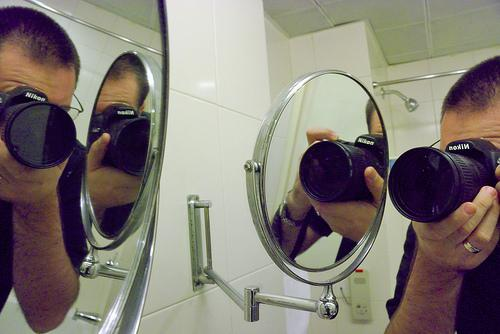Question: what is the man doing?
Choices:
A. Taking a picture.
B. Posing for a photo.
C. Eating an apple.
D. Drinking his beer.
Answer with the letter. Answer: A Question: what is the man holding?
Choices:
A. A beer.
B. A water bottle.
C. A camera.
D. An umbrella.
Answer with the letter. Answer: C Question: how many rings is the man wearing?
Choices:
A. Two.
B. Three.
C. Ten.
D. One.
Answer with the letter. Answer: D 